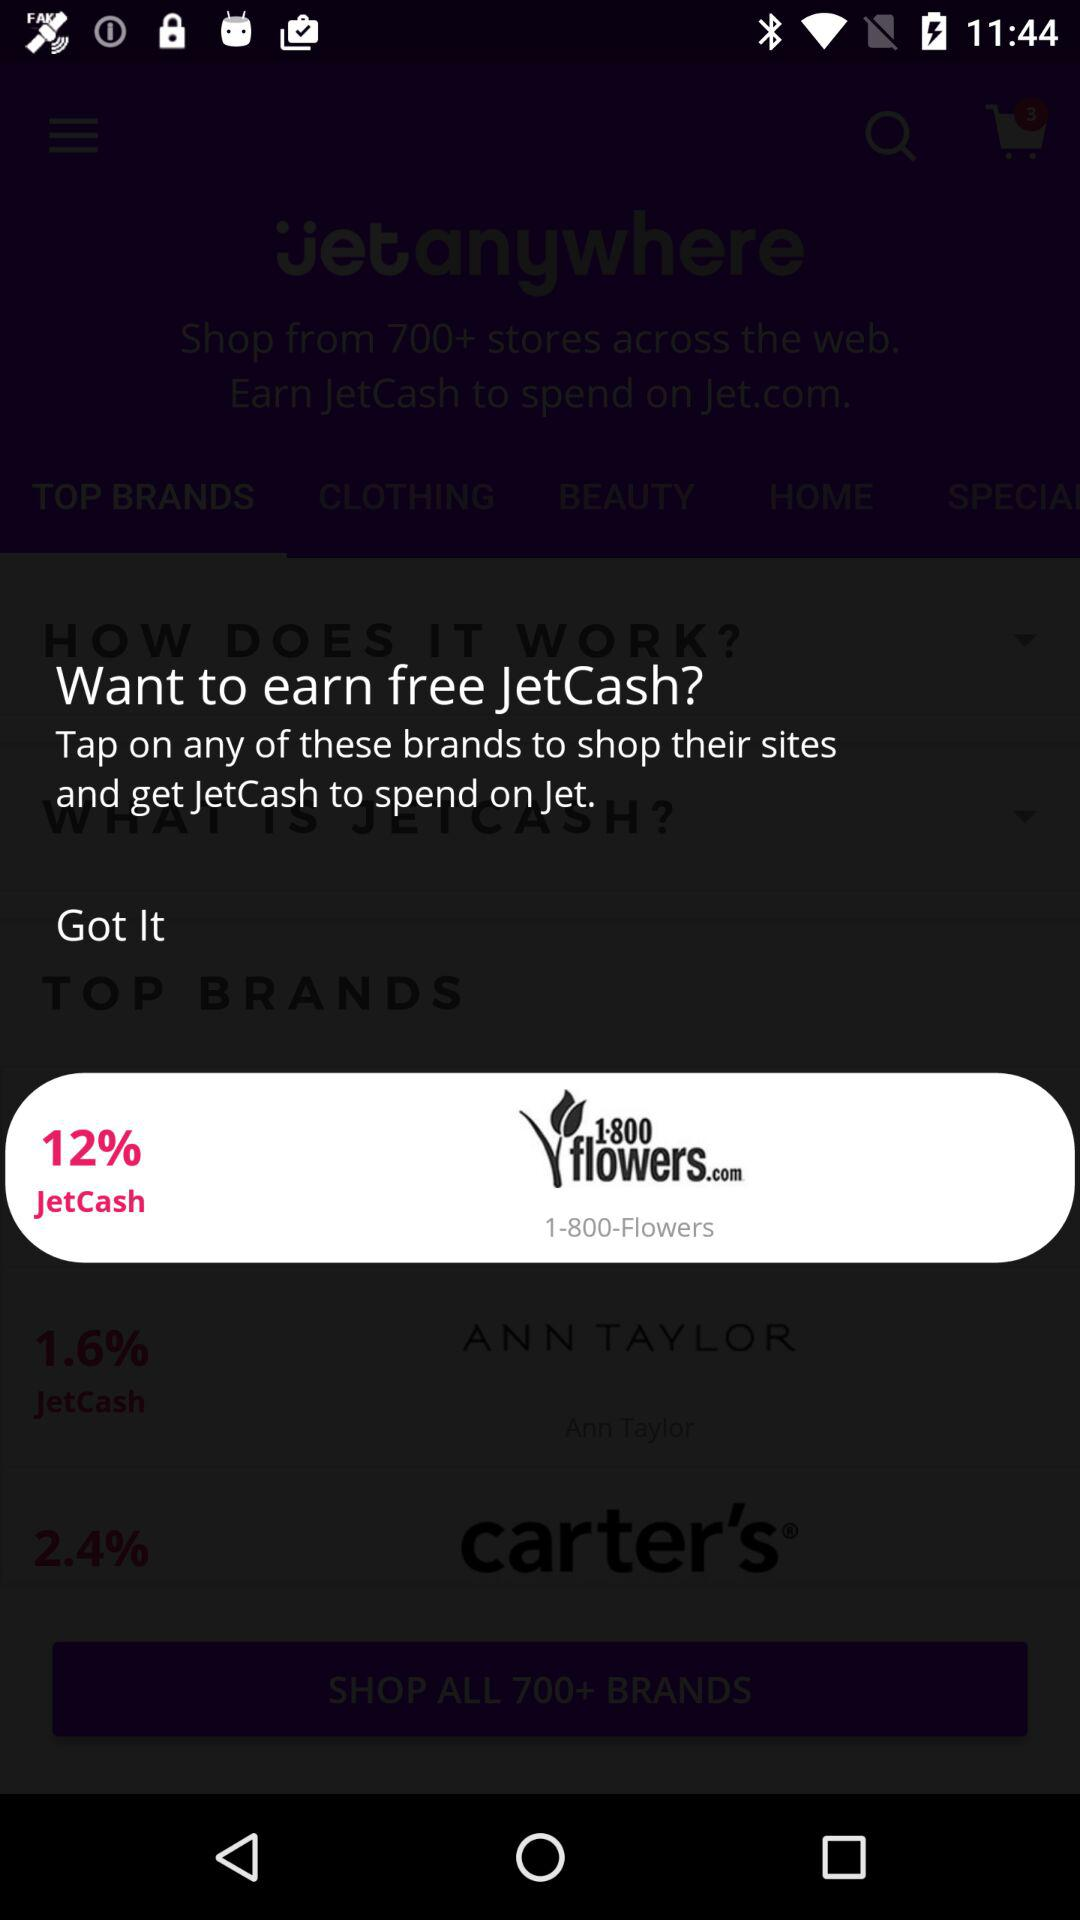How much JetCash can I earn by shopping at 1-800-Flowers?
Answer the question using a single word or phrase. 12% 